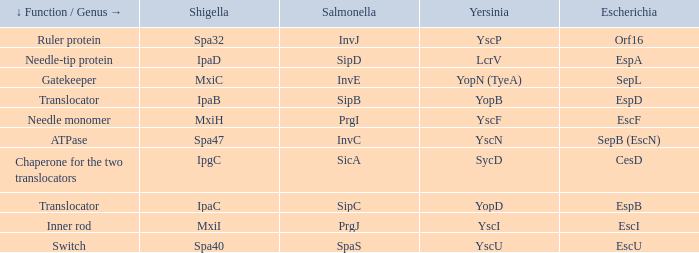Tell me the shigella and yscn Spa47. 